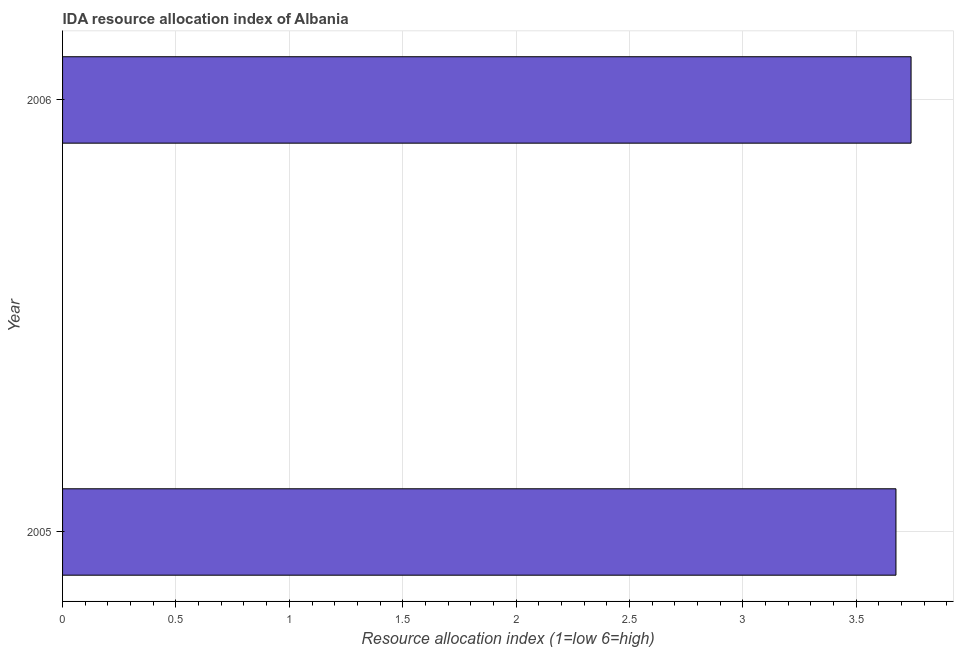Does the graph contain grids?
Keep it short and to the point. Yes. What is the title of the graph?
Offer a terse response. IDA resource allocation index of Albania. What is the label or title of the X-axis?
Provide a short and direct response. Resource allocation index (1=low 6=high). What is the label or title of the Y-axis?
Make the answer very short. Year. What is the ida resource allocation index in 2005?
Offer a terse response. 3.67. Across all years, what is the maximum ida resource allocation index?
Ensure brevity in your answer.  3.74. Across all years, what is the minimum ida resource allocation index?
Provide a succinct answer. 3.67. What is the sum of the ida resource allocation index?
Your response must be concise. 7.42. What is the difference between the ida resource allocation index in 2005 and 2006?
Offer a very short reply. -0.07. What is the average ida resource allocation index per year?
Offer a terse response. 3.71. What is the median ida resource allocation index?
Provide a short and direct response. 3.71. In how many years, is the ida resource allocation index greater than 2.8 ?
Offer a very short reply. 2. Do a majority of the years between 2006 and 2005 (inclusive) have ida resource allocation index greater than 0.3 ?
Your response must be concise. No. What is the ratio of the ida resource allocation index in 2005 to that in 2006?
Keep it short and to the point. 0.98. Is the ida resource allocation index in 2005 less than that in 2006?
Make the answer very short. Yes. In how many years, is the ida resource allocation index greater than the average ida resource allocation index taken over all years?
Offer a terse response. 1. How many bars are there?
Offer a very short reply. 2. Are all the bars in the graph horizontal?
Your response must be concise. Yes. What is the difference between two consecutive major ticks on the X-axis?
Your response must be concise. 0.5. What is the Resource allocation index (1=low 6=high) of 2005?
Offer a very short reply. 3.67. What is the Resource allocation index (1=low 6=high) of 2006?
Keep it short and to the point. 3.74. What is the difference between the Resource allocation index (1=low 6=high) in 2005 and 2006?
Offer a very short reply. -0.07. 